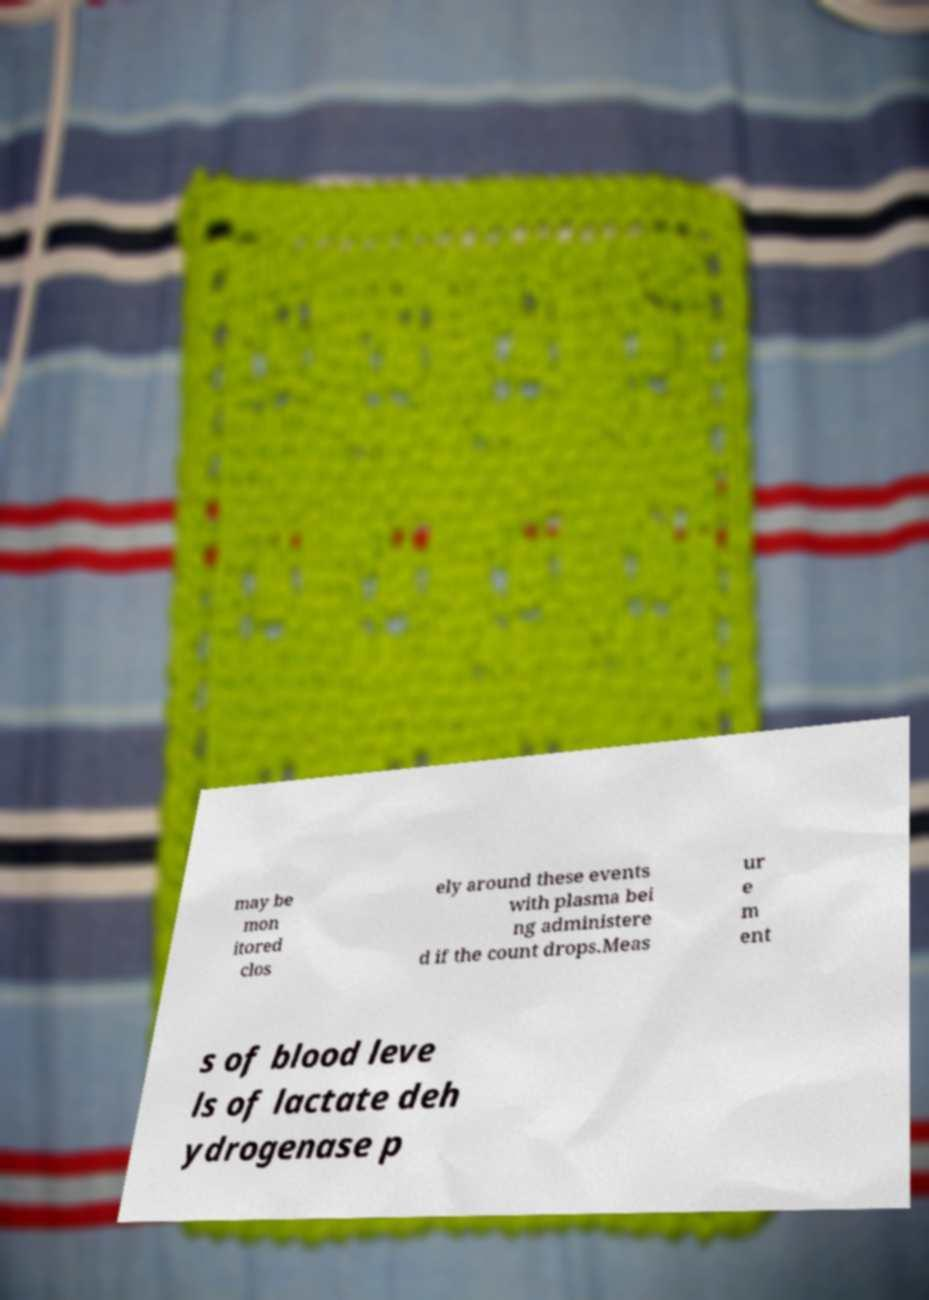Can you read and provide the text displayed in the image?This photo seems to have some interesting text. Can you extract and type it out for me? may be mon itored clos ely around these events with plasma bei ng administere d if the count drops.Meas ur e m ent s of blood leve ls of lactate deh ydrogenase p 